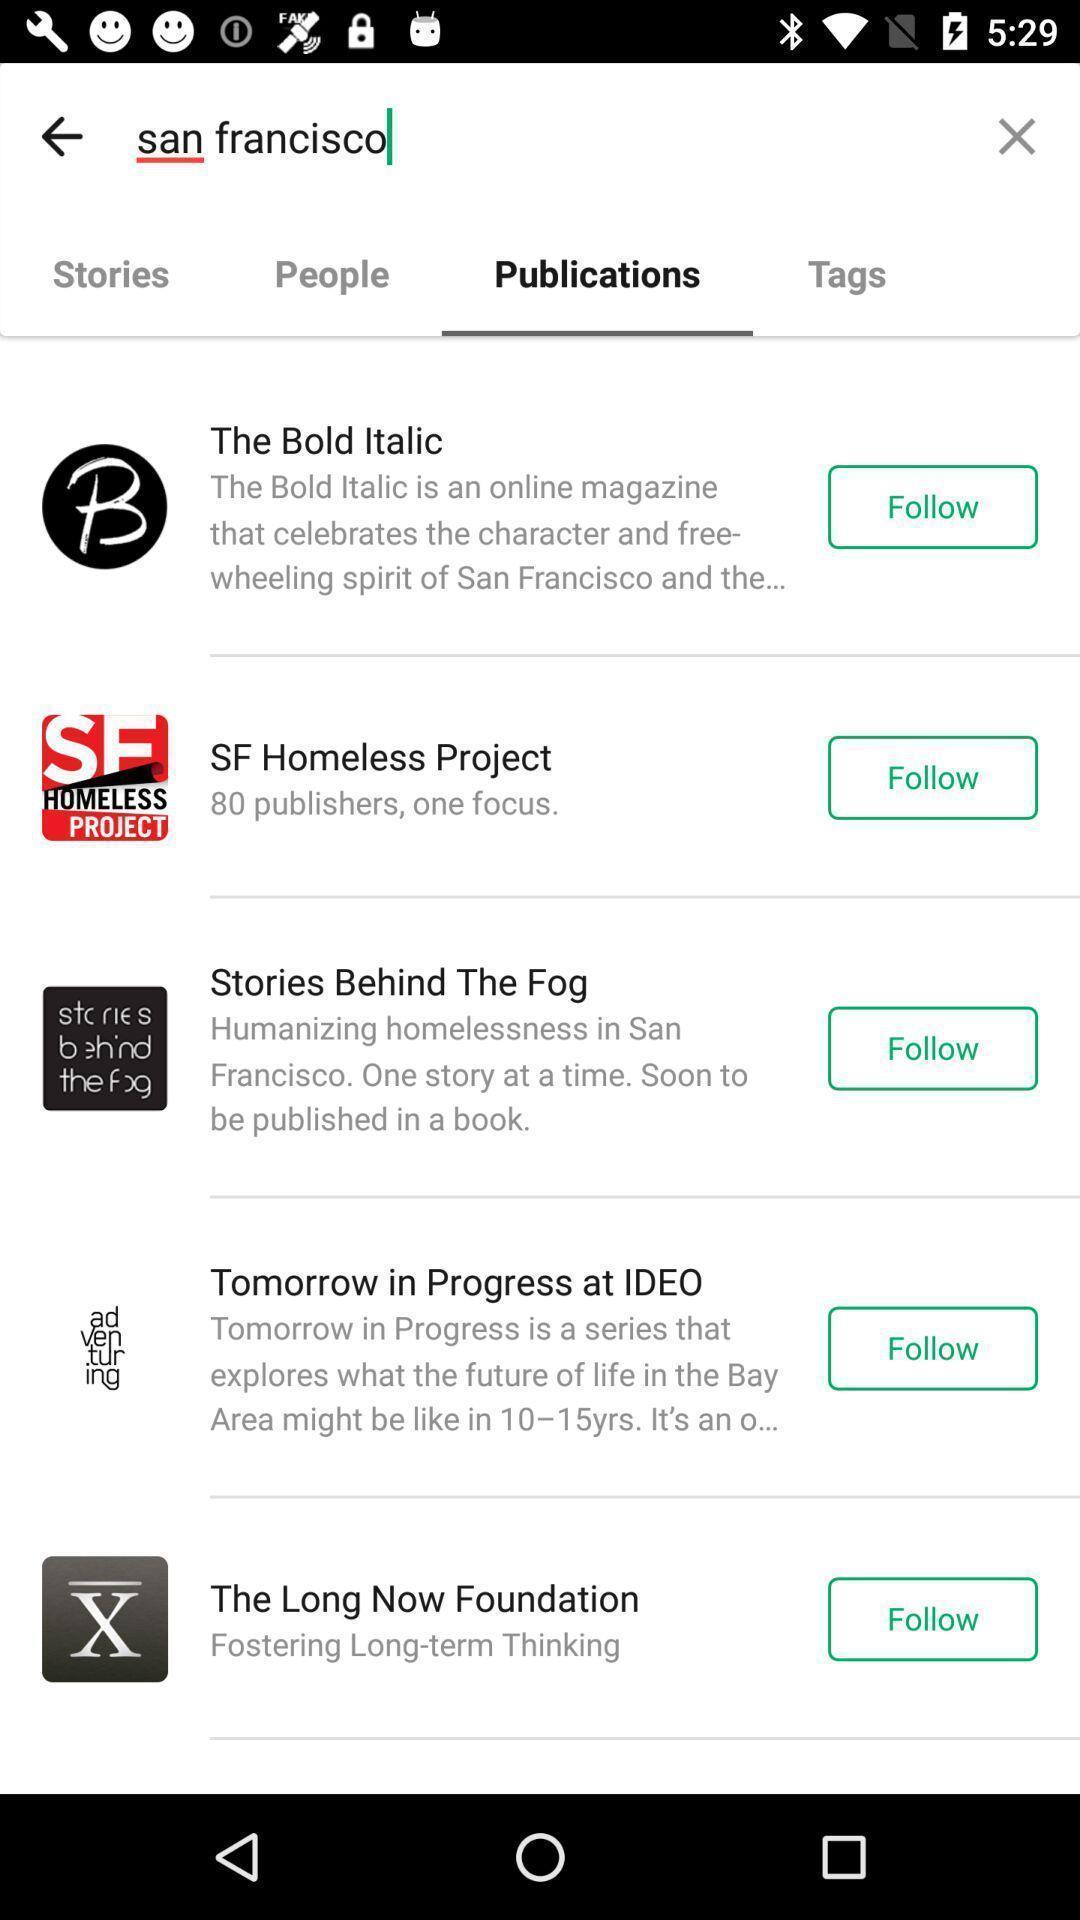What is the overall content of this screenshot? Social app showing list of publications. 